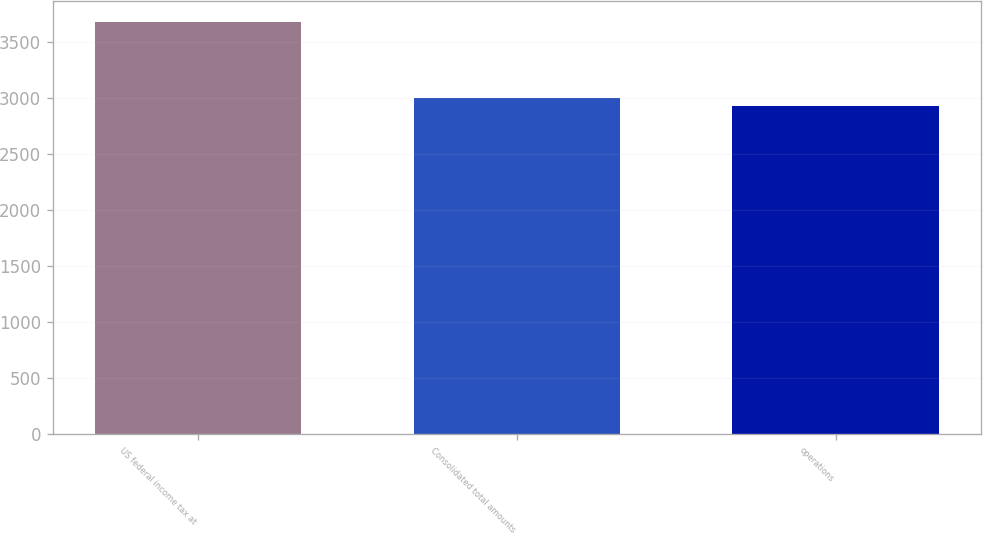<chart> <loc_0><loc_0><loc_500><loc_500><bar_chart><fcel>US federal income tax at<fcel>Consolidated total amounts<fcel>operations<nl><fcel>3683<fcel>3002.6<fcel>2927<nl></chart> 